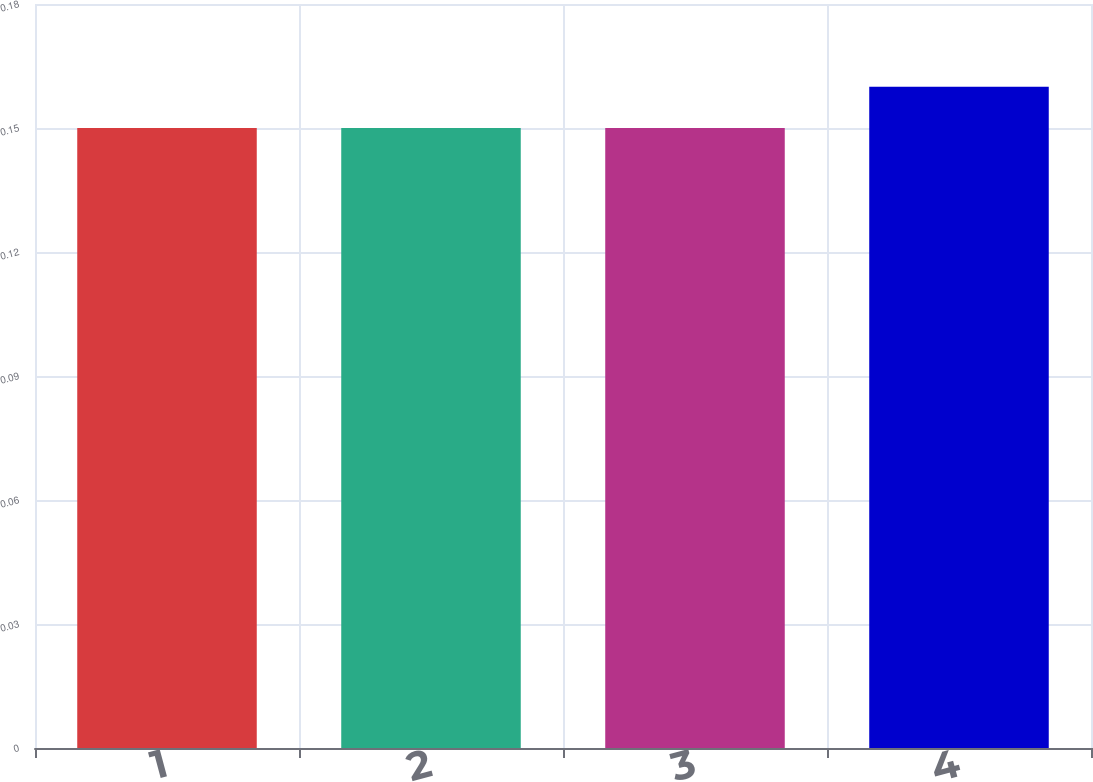Convert chart to OTSL. <chart><loc_0><loc_0><loc_500><loc_500><bar_chart><fcel>1<fcel>2<fcel>3<fcel>4<nl><fcel>0.15<fcel>0.15<fcel>0.15<fcel>0.16<nl></chart> 